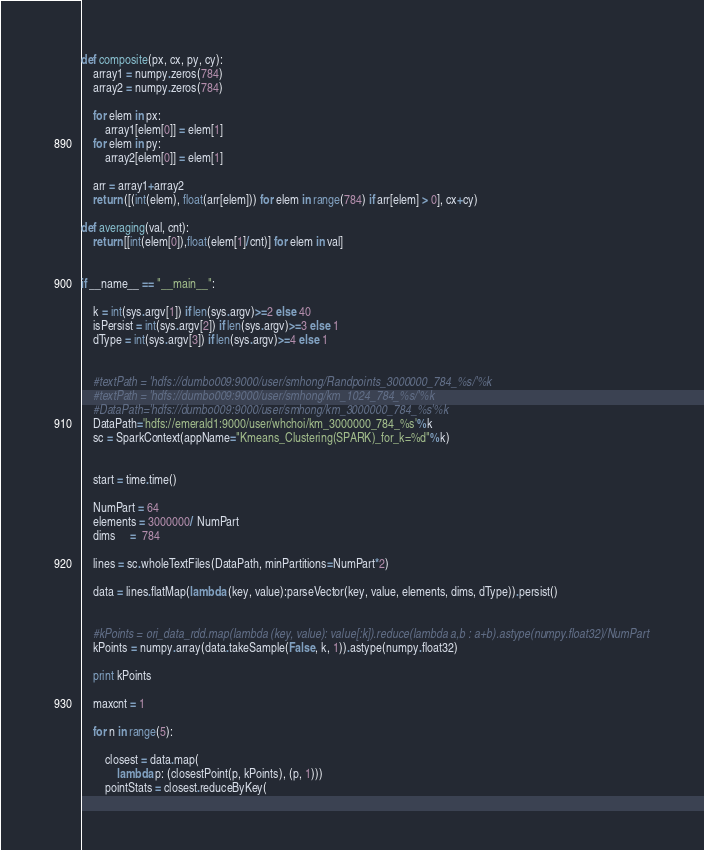Convert code to text. <code><loc_0><loc_0><loc_500><loc_500><_Python_>def composite(px, cx, py, cy):
    array1 = numpy.zeros(784)
    array2 = numpy.zeros(784)

    for elem in px:
        array1[elem[0]] = elem[1]
    for elem in py:
        array2[elem[0]] = elem[1]

    arr = array1+array2
    return ([(int(elem), float(arr[elem])) for elem in range(784) if arr[elem] > 0], cx+cy)

def averaging(val, cnt):
    return [[int(elem[0]),float(elem[1]/cnt)] for elem in val]


if __name__ == "__main__":

    k = int(sys.argv[1]) if len(sys.argv)>=2 else 40
    isPersist = int(sys.argv[2]) if len(sys.argv)>=3 else 1
    dType = int(sys.argv[3]) if len(sys.argv)>=4 else 1


    #textPath = 'hdfs://dumbo009:9000/user/smhong/Randpoints_3000000_784_%s/'%k
    #textPath = 'hdfs://dumbo009:9000/user/smhong/km_1024_784_%s/'%k
    #DataPath='hdfs://dumbo009:9000/user/smhong/km_3000000_784_%s'%k
    DataPath='hdfs://emerald1:9000/user/whchoi/km_3000000_784_%s'%k
    sc = SparkContext(appName="Kmeans_Clustering(SPARK)_for_k=%d"%k)

 
    start = time.time()

    NumPart = 64
    elements = 3000000/ NumPart
    dims     =  784

    lines = sc.wholeTextFiles(DataPath, minPartitions=NumPart*2)

    data = lines.flatMap(lambda (key, value):parseVector(key, value, elements, dims, dType)).persist()
 
    
    #kPoints = ori_data_rdd.map(lambda (key, value): value[:k]).reduce(lambda a,b : a+b).astype(numpy.float32)/NumPart
    kPoints = numpy.array(data.takeSample(False, k, 1)).astype(numpy.float32)

    print kPoints

    maxcnt = 1
    
    for n in range(5): 

        closest = data.map(
            lambda p: (closestPoint(p, kPoints), (p, 1)))
        pointStats = closest.reduceByKey(</code> 